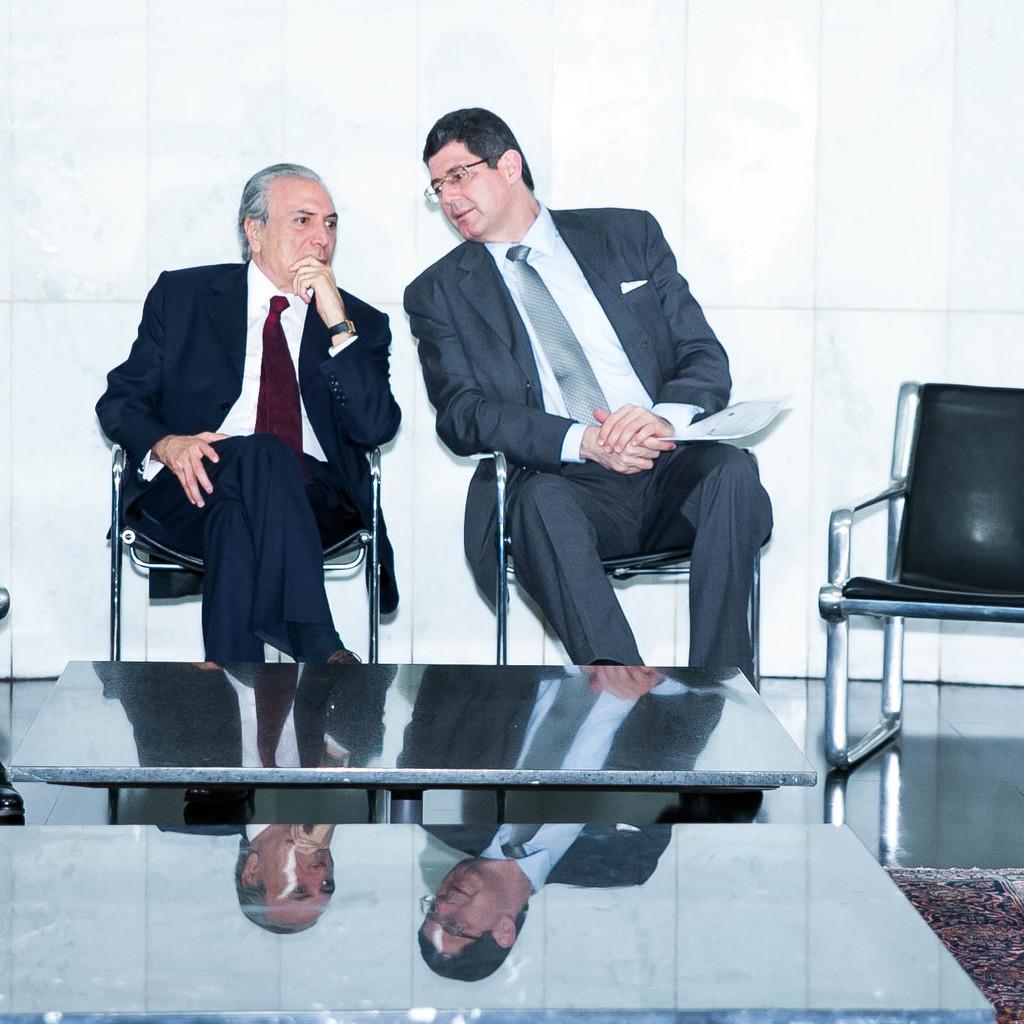Describe this image in one or two sentences. There are two people sitting on chair. Person on the right is holding a paper and wearing a specs. In front of them there are tables. Also a chair is in the right side. In the background there is a wall. 